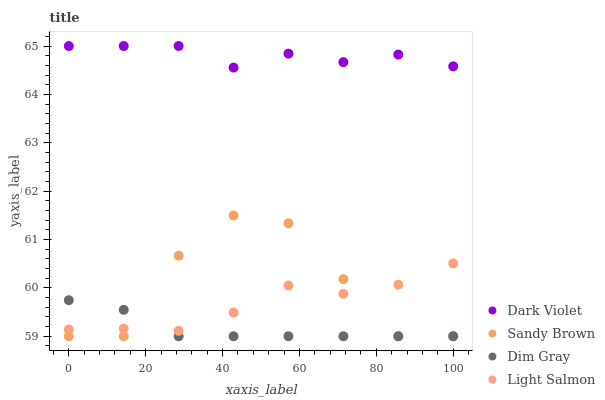Does Dim Gray have the minimum area under the curve?
Answer yes or no. Yes. Does Dark Violet have the maximum area under the curve?
Answer yes or no. Yes. Does Sandy Brown have the minimum area under the curve?
Answer yes or no. No. Does Sandy Brown have the maximum area under the curve?
Answer yes or no. No. Is Dim Gray the smoothest?
Answer yes or no. Yes. Is Sandy Brown the roughest?
Answer yes or no. Yes. Is Sandy Brown the smoothest?
Answer yes or no. No. Is Dim Gray the roughest?
Answer yes or no. No. Does Dim Gray have the lowest value?
Answer yes or no. Yes. Does Dark Violet have the lowest value?
Answer yes or no. No. Does Dark Violet have the highest value?
Answer yes or no. Yes. Does Sandy Brown have the highest value?
Answer yes or no. No. Is Dim Gray less than Dark Violet?
Answer yes or no. Yes. Is Dark Violet greater than Sandy Brown?
Answer yes or no. Yes. Does Light Salmon intersect Dim Gray?
Answer yes or no. Yes. Is Light Salmon less than Dim Gray?
Answer yes or no. No. Is Light Salmon greater than Dim Gray?
Answer yes or no. No. Does Dim Gray intersect Dark Violet?
Answer yes or no. No. 